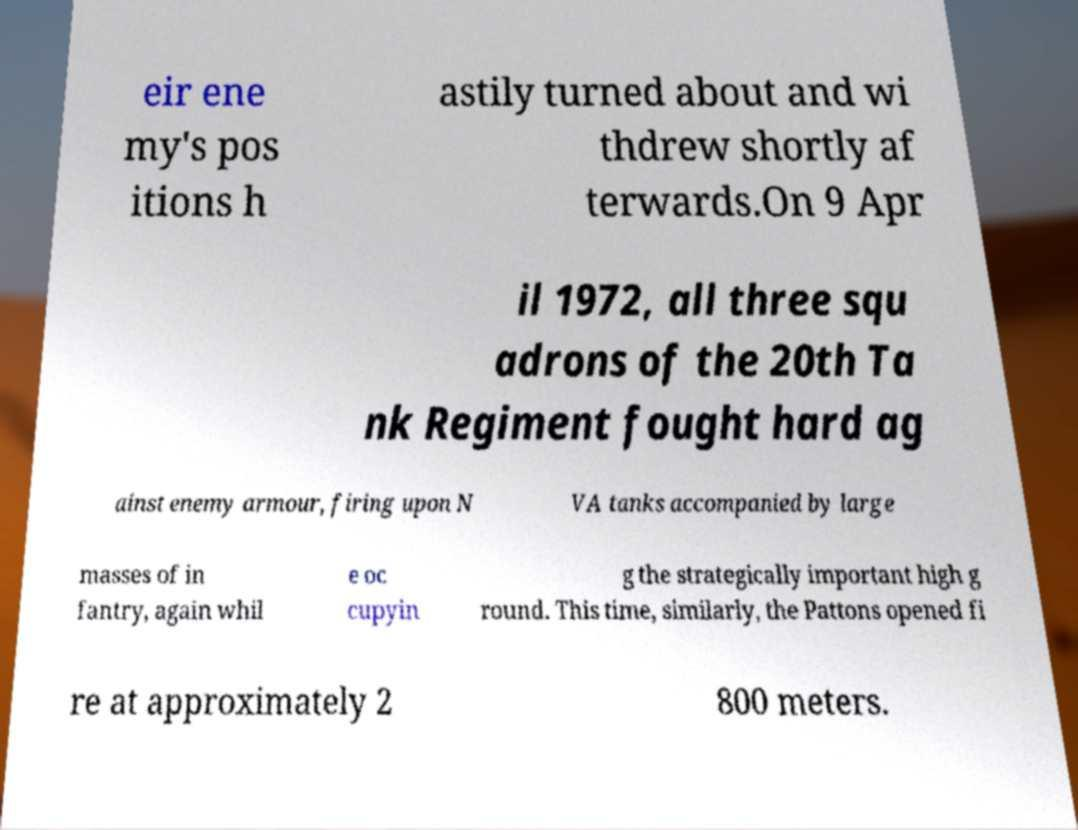There's text embedded in this image that I need extracted. Can you transcribe it verbatim? eir ene my's pos itions h astily turned about and wi thdrew shortly af terwards.On 9 Apr il 1972, all three squ adrons of the 20th Ta nk Regiment fought hard ag ainst enemy armour, firing upon N VA tanks accompanied by large masses of in fantry, again whil e oc cupyin g the strategically important high g round. This time, similarly, the Pattons opened fi re at approximately 2 800 meters. 